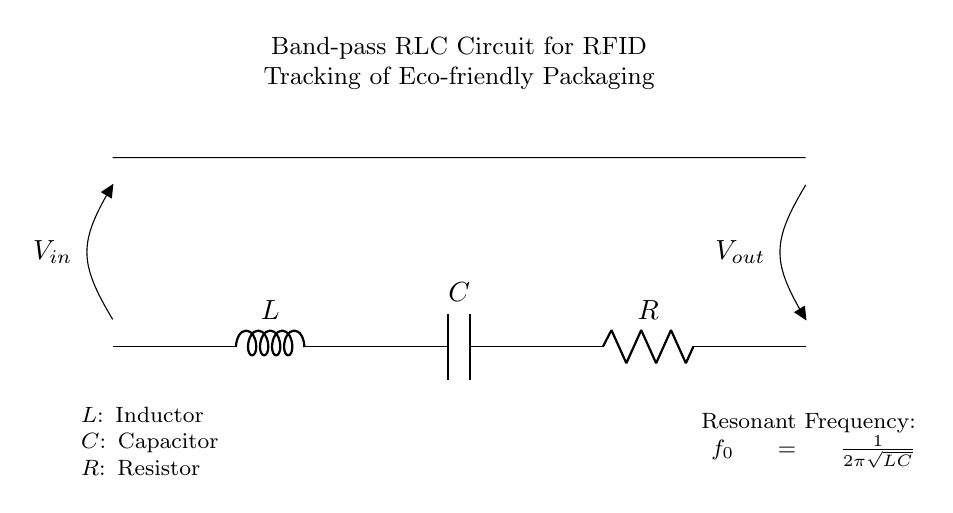What are the components present in this circuit? The circuit contains an inductor, a capacitor, and a resistor. These are labeled in the diagram as L, C, and R respectively.
Answer: Inductor, capacitor, resistor What is the purpose of this RLC circuit? The circuit is specifically designed as a band-pass filter for RFID tracking of eco-friendly packaging materials, allowing specific frequencies to pass while attenuating others.
Answer: Band-pass filter for RFID tracking What is the resonant frequency of this circuit? The resonant frequency, denoted as f0, can be calculated using the formula f0 = 1/(2π√(LC)). This indicates the frequency at which the circuit will resonate.
Answer: 1/(2π√(LC)) How are the components connected in the circuit? The inductor is connected in series with the capacitor, which is then connected in series with the resistor. Each component is aligned along the same path of current flow.
Answer: In series What happens to the output voltage when the input frequency equals the resonant frequency? At resonant frequency, the impedance of the circuit is minimized and maximum current flows, resulting in a peak output voltage. This is a characteristic behavior of band-pass filters.
Answer: Peak output voltage How does increasing the value of the resistor affect the circuit's performance? Increasing the resistance will lower the quality factor (Q) of the circuit, resulting in a wider bandwidth but lower peak amplitude at resonant frequency, making it less selective for frequencies.
Answer: Lower quality factor What can be inferred about the type of signal this circuit is expected to handle? The circuit is designed to handle signals at or near the resonant frequency, meaning it is optimized for specific frequencies pertinent to RFID applications in eco-friendly packaging.
Answer: Specific frequencies for RFID 